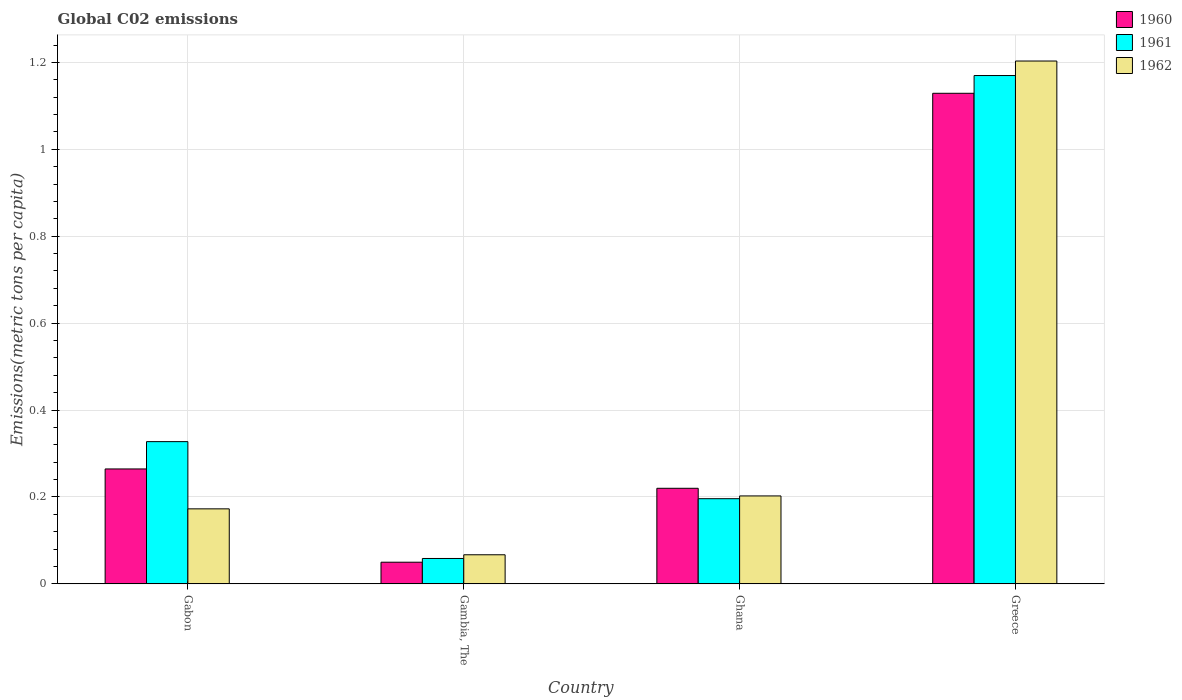Are the number of bars on each tick of the X-axis equal?
Your response must be concise. Yes. How many bars are there on the 4th tick from the left?
Keep it short and to the point. 3. What is the label of the 3rd group of bars from the left?
Ensure brevity in your answer.  Ghana. What is the amount of CO2 emitted in in 1962 in Gabon?
Offer a terse response. 0.17. Across all countries, what is the maximum amount of CO2 emitted in in 1961?
Your answer should be very brief. 1.17. Across all countries, what is the minimum amount of CO2 emitted in in 1960?
Provide a succinct answer. 0.05. In which country was the amount of CO2 emitted in in 1962 maximum?
Offer a very short reply. Greece. In which country was the amount of CO2 emitted in in 1961 minimum?
Keep it short and to the point. Gambia, The. What is the total amount of CO2 emitted in in 1961 in the graph?
Your answer should be very brief. 1.75. What is the difference between the amount of CO2 emitted in in 1962 in Ghana and that in Greece?
Offer a terse response. -1. What is the difference between the amount of CO2 emitted in in 1961 in Gabon and the amount of CO2 emitted in in 1960 in Ghana?
Make the answer very short. 0.11. What is the average amount of CO2 emitted in in 1962 per country?
Provide a short and direct response. 0.41. What is the difference between the amount of CO2 emitted in of/in 1962 and amount of CO2 emitted in of/in 1960 in Ghana?
Your answer should be very brief. -0.02. In how many countries, is the amount of CO2 emitted in in 1962 greater than 0.2 metric tons per capita?
Ensure brevity in your answer.  2. What is the ratio of the amount of CO2 emitted in in 1962 in Gabon to that in Ghana?
Your response must be concise. 0.85. Is the amount of CO2 emitted in in 1960 in Gabon less than that in Greece?
Make the answer very short. Yes. Is the difference between the amount of CO2 emitted in in 1962 in Gabon and Ghana greater than the difference between the amount of CO2 emitted in in 1960 in Gabon and Ghana?
Provide a short and direct response. No. What is the difference between the highest and the second highest amount of CO2 emitted in in 1960?
Provide a succinct answer. -0.86. What is the difference between the highest and the lowest amount of CO2 emitted in in 1960?
Keep it short and to the point. 1.08. In how many countries, is the amount of CO2 emitted in in 1961 greater than the average amount of CO2 emitted in in 1961 taken over all countries?
Keep it short and to the point. 1. Is the sum of the amount of CO2 emitted in in 1961 in Gabon and Ghana greater than the maximum amount of CO2 emitted in in 1962 across all countries?
Your answer should be compact. No. What does the 3rd bar from the left in Greece represents?
Your answer should be very brief. 1962. Is it the case that in every country, the sum of the amount of CO2 emitted in in 1962 and amount of CO2 emitted in in 1960 is greater than the amount of CO2 emitted in in 1961?
Make the answer very short. Yes. How many bars are there?
Ensure brevity in your answer.  12. Are the values on the major ticks of Y-axis written in scientific E-notation?
Keep it short and to the point. No. Does the graph contain any zero values?
Provide a short and direct response. No. Where does the legend appear in the graph?
Make the answer very short. Top right. What is the title of the graph?
Your answer should be very brief. Global C02 emissions. What is the label or title of the X-axis?
Keep it short and to the point. Country. What is the label or title of the Y-axis?
Offer a very short reply. Emissions(metric tons per capita). What is the Emissions(metric tons per capita) in 1960 in Gabon?
Give a very brief answer. 0.26. What is the Emissions(metric tons per capita) in 1961 in Gabon?
Keep it short and to the point. 0.33. What is the Emissions(metric tons per capita) in 1962 in Gabon?
Your answer should be very brief. 0.17. What is the Emissions(metric tons per capita) of 1960 in Gambia, The?
Provide a short and direct response. 0.05. What is the Emissions(metric tons per capita) in 1961 in Gambia, The?
Keep it short and to the point. 0.06. What is the Emissions(metric tons per capita) in 1962 in Gambia, The?
Offer a terse response. 0.07. What is the Emissions(metric tons per capita) of 1960 in Ghana?
Give a very brief answer. 0.22. What is the Emissions(metric tons per capita) in 1961 in Ghana?
Your answer should be very brief. 0.2. What is the Emissions(metric tons per capita) in 1962 in Ghana?
Your response must be concise. 0.2. What is the Emissions(metric tons per capita) in 1960 in Greece?
Keep it short and to the point. 1.13. What is the Emissions(metric tons per capita) in 1961 in Greece?
Ensure brevity in your answer.  1.17. What is the Emissions(metric tons per capita) in 1962 in Greece?
Your answer should be compact. 1.2. Across all countries, what is the maximum Emissions(metric tons per capita) in 1960?
Keep it short and to the point. 1.13. Across all countries, what is the maximum Emissions(metric tons per capita) of 1961?
Provide a succinct answer. 1.17. Across all countries, what is the maximum Emissions(metric tons per capita) in 1962?
Your answer should be compact. 1.2. Across all countries, what is the minimum Emissions(metric tons per capita) in 1960?
Offer a terse response. 0.05. Across all countries, what is the minimum Emissions(metric tons per capita) in 1961?
Offer a very short reply. 0.06. Across all countries, what is the minimum Emissions(metric tons per capita) of 1962?
Make the answer very short. 0.07. What is the total Emissions(metric tons per capita) of 1960 in the graph?
Provide a succinct answer. 1.66. What is the total Emissions(metric tons per capita) of 1961 in the graph?
Your answer should be compact. 1.75. What is the total Emissions(metric tons per capita) of 1962 in the graph?
Offer a very short reply. 1.65. What is the difference between the Emissions(metric tons per capita) of 1960 in Gabon and that in Gambia, The?
Your answer should be very brief. 0.21. What is the difference between the Emissions(metric tons per capita) of 1961 in Gabon and that in Gambia, The?
Provide a succinct answer. 0.27. What is the difference between the Emissions(metric tons per capita) in 1962 in Gabon and that in Gambia, The?
Offer a very short reply. 0.11. What is the difference between the Emissions(metric tons per capita) in 1960 in Gabon and that in Ghana?
Provide a succinct answer. 0.04. What is the difference between the Emissions(metric tons per capita) in 1961 in Gabon and that in Ghana?
Offer a very short reply. 0.13. What is the difference between the Emissions(metric tons per capita) in 1962 in Gabon and that in Ghana?
Your answer should be compact. -0.03. What is the difference between the Emissions(metric tons per capita) in 1960 in Gabon and that in Greece?
Your answer should be very brief. -0.86. What is the difference between the Emissions(metric tons per capita) in 1961 in Gabon and that in Greece?
Your answer should be compact. -0.84. What is the difference between the Emissions(metric tons per capita) of 1962 in Gabon and that in Greece?
Offer a very short reply. -1.03. What is the difference between the Emissions(metric tons per capita) in 1960 in Gambia, The and that in Ghana?
Make the answer very short. -0.17. What is the difference between the Emissions(metric tons per capita) in 1961 in Gambia, The and that in Ghana?
Ensure brevity in your answer.  -0.14. What is the difference between the Emissions(metric tons per capita) in 1962 in Gambia, The and that in Ghana?
Your answer should be very brief. -0.14. What is the difference between the Emissions(metric tons per capita) of 1960 in Gambia, The and that in Greece?
Keep it short and to the point. -1.08. What is the difference between the Emissions(metric tons per capita) of 1961 in Gambia, The and that in Greece?
Your answer should be very brief. -1.11. What is the difference between the Emissions(metric tons per capita) in 1962 in Gambia, The and that in Greece?
Keep it short and to the point. -1.14. What is the difference between the Emissions(metric tons per capita) of 1960 in Ghana and that in Greece?
Give a very brief answer. -0.91. What is the difference between the Emissions(metric tons per capita) in 1961 in Ghana and that in Greece?
Ensure brevity in your answer.  -0.97. What is the difference between the Emissions(metric tons per capita) in 1962 in Ghana and that in Greece?
Provide a succinct answer. -1. What is the difference between the Emissions(metric tons per capita) of 1960 in Gabon and the Emissions(metric tons per capita) of 1961 in Gambia, The?
Offer a terse response. 0.21. What is the difference between the Emissions(metric tons per capita) in 1960 in Gabon and the Emissions(metric tons per capita) in 1962 in Gambia, The?
Your answer should be very brief. 0.2. What is the difference between the Emissions(metric tons per capita) of 1961 in Gabon and the Emissions(metric tons per capita) of 1962 in Gambia, The?
Offer a very short reply. 0.26. What is the difference between the Emissions(metric tons per capita) of 1960 in Gabon and the Emissions(metric tons per capita) of 1961 in Ghana?
Provide a short and direct response. 0.07. What is the difference between the Emissions(metric tons per capita) of 1960 in Gabon and the Emissions(metric tons per capita) of 1962 in Ghana?
Your response must be concise. 0.06. What is the difference between the Emissions(metric tons per capita) in 1961 in Gabon and the Emissions(metric tons per capita) in 1962 in Ghana?
Provide a short and direct response. 0.12. What is the difference between the Emissions(metric tons per capita) in 1960 in Gabon and the Emissions(metric tons per capita) in 1961 in Greece?
Make the answer very short. -0.91. What is the difference between the Emissions(metric tons per capita) in 1960 in Gabon and the Emissions(metric tons per capita) in 1962 in Greece?
Your answer should be compact. -0.94. What is the difference between the Emissions(metric tons per capita) of 1961 in Gabon and the Emissions(metric tons per capita) of 1962 in Greece?
Your response must be concise. -0.88. What is the difference between the Emissions(metric tons per capita) of 1960 in Gambia, The and the Emissions(metric tons per capita) of 1961 in Ghana?
Keep it short and to the point. -0.15. What is the difference between the Emissions(metric tons per capita) of 1960 in Gambia, The and the Emissions(metric tons per capita) of 1962 in Ghana?
Ensure brevity in your answer.  -0.15. What is the difference between the Emissions(metric tons per capita) in 1961 in Gambia, The and the Emissions(metric tons per capita) in 1962 in Ghana?
Ensure brevity in your answer.  -0.14. What is the difference between the Emissions(metric tons per capita) in 1960 in Gambia, The and the Emissions(metric tons per capita) in 1961 in Greece?
Make the answer very short. -1.12. What is the difference between the Emissions(metric tons per capita) of 1960 in Gambia, The and the Emissions(metric tons per capita) of 1962 in Greece?
Make the answer very short. -1.15. What is the difference between the Emissions(metric tons per capita) of 1961 in Gambia, The and the Emissions(metric tons per capita) of 1962 in Greece?
Make the answer very short. -1.14. What is the difference between the Emissions(metric tons per capita) in 1960 in Ghana and the Emissions(metric tons per capita) in 1961 in Greece?
Your response must be concise. -0.95. What is the difference between the Emissions(metric tons per capita) of 1960 in Ghana and the Emissions(metric tons per capita) of 1962 in Greece?
Provide a short and direct response. -0.98. What is the difference between the Emissions(metric tons per capita) of 1961 in Ghana and the Emissions(metric tons per capita) of 1962 in Greece?
Keep it short and to the point. -1.01. What is the average Emissions(metric tons per capita) in 1960 per country?
Offer a terse response. 0.42. What is the average Emissions(metric tons per capita) in 1961 per country?
Your answer should be very brief. 0.44. What is the average Emissions(metric tons per capita) in 1962 per country?
Your response must be concise. 0.41. What is the difference between the Emissions(metric tons per capita) of 1960 and Emissions(metric tons per capita) of 1961 in Gabon?
Keep it short and to the point. -0.06. What is the difference between the Emissions(metric tons per capita) of 1960 and Emissions(metric tons per capita) of 1962 in Gabon?
Keep it short and to the point. 0.09. What is the difference between the Emissions(metric tons per capita) of 1961 and Emissions(metric tons per capita) of 1962 in Gabon?
Ensure brevity in your answer.  0.15. What is the difference between the Emissions(metric tons per capita) of 1960 and Emissions(metric tons per capita) of 1961 in Gambia, The?
Offer a terse response. -0.01. What is the difference between the Emissions(metric tons per capita) in 1960 and Emissions(metric tons per capita) in 1962 in Gambia, The?
Make the answer very short. -0.02. What is the difference between the Emissions(metric tons per capita) in 1961 and Emissions(metric tons per capita) in 1962 in Gambia, The?
Keep it short and to the point. -0.01. What is the difference between the Emissions(metric tons per capita) of 1960 and Emissions(metric tons per capita) of 1961 in Ghana?
Keep it short and to the point. 0.02. What is the difference between the Emissions(metric tons per capita) in 1960 and Emissions(metric tons per capita) in 1962 in Ghana?
Your answer should be very brief. 0.02. What is the difference between the Emissions(metric tons per capita) of 1961 and Emissions(metric tons per capita) of 1962 in Ghana?
Make the answer very short. -0.01. What is the difference between the Emissions(metric tons per capita) of 1960 and Emissions(metric tons per capita) of 1961 in Greece?
Offer a very short reply. -0.04. What is the difference between the Emissions(metric tons per capita) of 1960 and Emissions(metric tons per capita) of 1962 in Greece?
Your answer should be very brief. -0.07. What is the difference between the Emissions(metric tons per capita) of 1961 and Emissions(metric tons per capita) of 1962 in Greece?
Ensure brevity in your answer.  -0.03. What is the ratio of the Emissions(metric tons per capita) of 1960 in Gabon to that in Gambia, The?
Your response must be concise. 5.31. What is the ratio of the Emissions(metric tons per capita) of 1961 in Gabon to that in Gambia, The?
Offer a terse response. 5.6. What is the ratio of the Emissions(metric tons per capita) of 1962 in Gabon to that in Gambia, The?
Give a very brief answer. 2.58. What is the ratio of the Emissions(metric tons per capita) of 1960 in Gabon to that in Ghana?
Offer a very short reply. 1.2. What is the ratio of the Emissions(metric tons per capita) of 1961 in Gabon to that in Ghana?
Your response must be concise. 1.67. What is the ratio of the Emissions(metric tons per capita) of 1962 in Gabon to that in Ghana?
Provide a succinct answer. 0.85. What is the ratio of the Emissions(metric tons per capita) of 1960 in Gabon to that in Greece?
Your answer should be compact. 0.23. What is the ratio of the Emissions(metric tons per capita) of 1961 in Gabon to that in Greece?
Keep it short and to the point. 0.28. What is the ratio of the Emissions(metric tons per capita) in 1962 in Gabon to that in Greece?
Make the answer very short. 0.14. What is the ratio of the Emissions(metric tons per capita) of 1960 in Gambia, The to that in Ghana?
Keep it short and to the point. 0.23. What is the ratio of the Emissions(metric tons per capita) in 1961 in Gambia, The to that in Ghana?
Offer a terse response. 0.3. What is the ratio of the Emissions(metric tons per capita) in 1962 in Gambia, The to that in Ghana?
Your answer should be very brief. 0.33. What is the ratio of the Emissions(metric tons per capita) of 1960 in Gambia, The to that in Greece?
Offer a terse response. 0.04. What is the ratio of the Emissions(metric tons per capita) of 1961 in Gambia, The to that in Greece?
Your response must be concise. 0.05. What is the ratio of the Emissions(metric tons per capita) in 1962 in Gambia, The to that in Greece?
Make the answer very short. 0.06. What is the ratio of the Emissions(metric tons per capita) of 1960 in Ghana to that in Greece?
Offer a very short reply. 0.19. What is the ratio of the Emissions(metric tons per capita) of 1961 in Ghana to that in Greece?
Provide a succinct answer. 0.17. What is the ratio of the Emissions(metric tons per capita) in 1962 in Ghana to that in Greece?
Keep it short and to the point. 0.17. What is the difference between the highest and the second highest Emissions(metric tons per capita) in 1960?
Give a very brief answer. 0.86. What is the difference between the highest and the second highest Emissions(metric tons per capita) in 1961?
Offer a very short reply. 0.84. What is the difference between the highest and the second highest Emissions(metric tons per capita) in 1962?
Your answer should be compact. 1. What is the difference between the highest and the lowest Emissions(metric tons per capita) of 1960?
Provide a succinct answer. 1.08. What is the difference between the highest and the lowest Emissions(metric tons per capita) of 1961?
Offer a very short reply. 1.11. What is the difference between the highest and the lowest Emissions(metric tons per capita) in 1962?
Offer a very short reply. 1.14. 